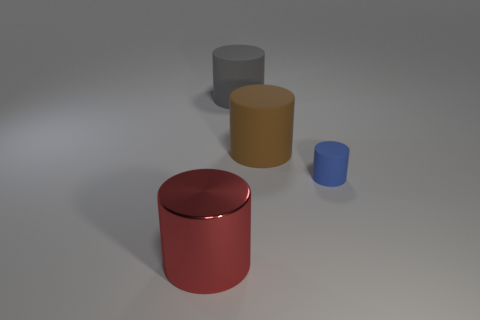There is a blue thing that is made of the same material as the large gray thing; what size is it?
Your answer should be compact. Small. Are there fewer big brown matte objects than rubber things?
Offer a very short reply. Yes. What number of large objects are either red matte balls or gray cylinders?
Your response must be concise. 1. What number of cylinders are both in front of the large gray object and on the left side of the tiny blue cylinder?
Your answer should be very brief. 2. Are there more large red shiny things than small yellow rubber balls?
Your answer should be compact. Yes. What number of other objects are there of the same shape as the big gray object?
Your response must be concise. 3. What is the material of the object that is both to the left of the big brown matte cylinder and behind the blue thing?
Keep it short and to the point. Rubber. How big is the blue object?
Provide a short and direct response. Small. How many brown matte objects are behind the big matte cylinder left of the large matte cylinder that is right of the gray thing?
Your answer should be very brief. 0. The object in front of the rubber cylinder that is on the right side of the brown matte thing is what shape?
Provide a short and direct response. Cylinder. 